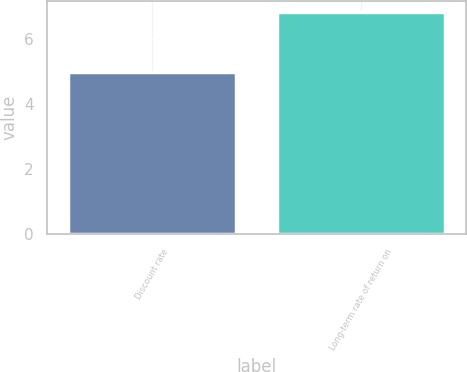<chart> <loc_0><loc_0><loc_500><loc_500><bar_chart><fcel>Discount rate<fcel>Long-term rate of return on<nl><fcel>4.96<fcel>6.8<nl></chart> 